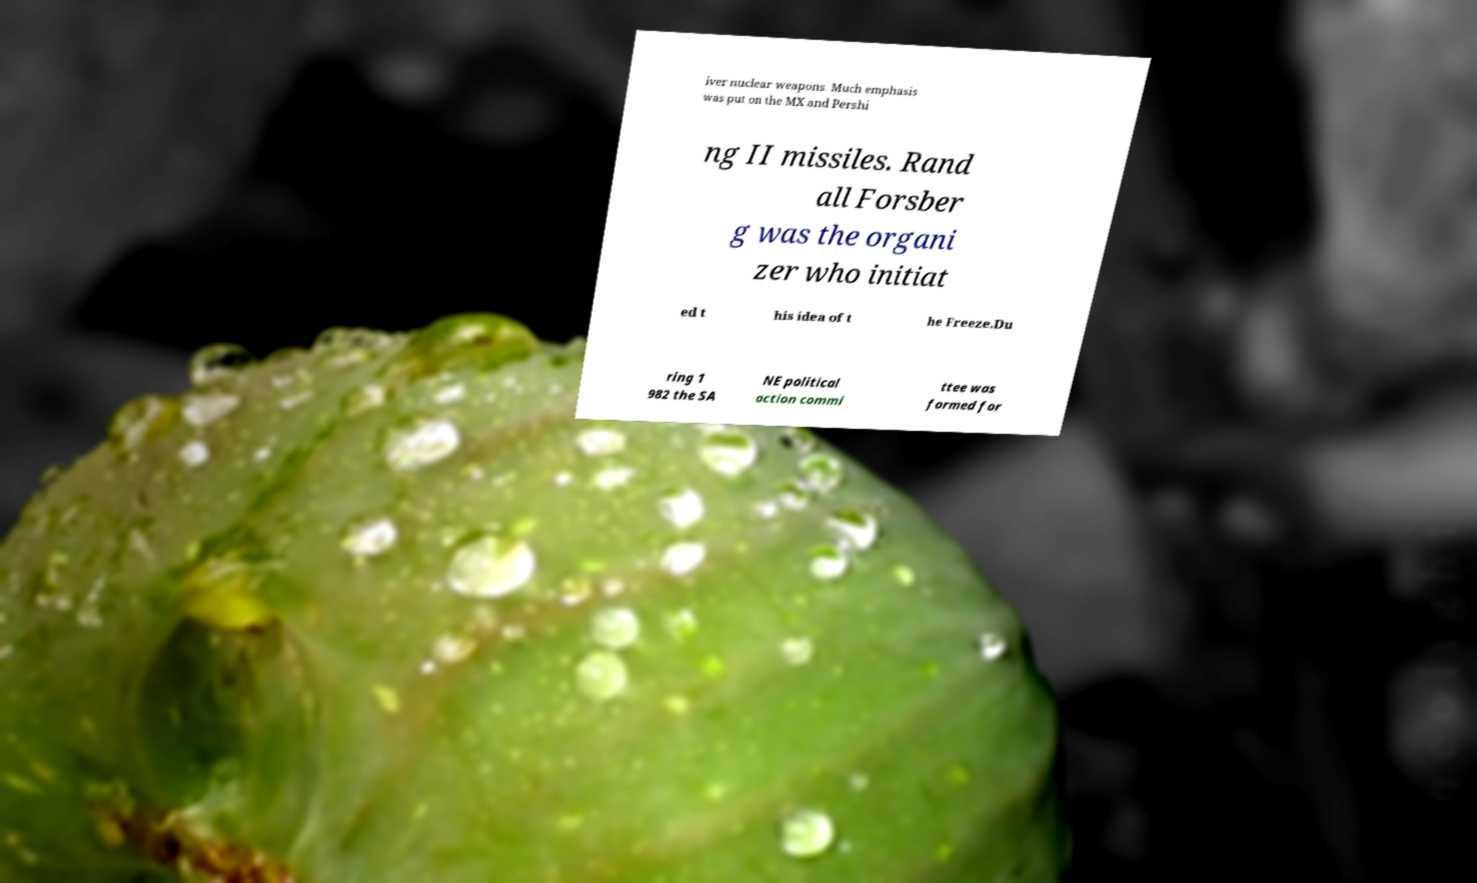For documentation purposes, I need the text within this image transcribed. Could you provide that? iver nuclear weapons. Much emphasis was put on the MX and Pershi ng II missiles. Rand all Forsber g was the organi zer who initiat ed t his idea of t he Freeze.Du ring 1 982 the SA NE political action commi ttee was formed for 